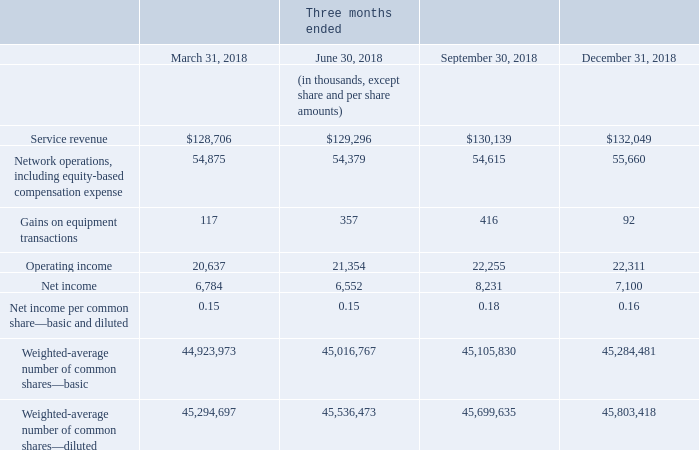11. Quarterly financial information (unaudited): (Continued)
(1) Included in net income for the three months ended September 30, 2019 and December 31, 2019 are an unrealized gain and (loss) on foreign exchange on the Company’s 2024 Notes of $6.1 million and ($4.0) million, respectively.
What are the respective service revenue at March 31 and June 30, 2018?
Answer scale should be: thousand. $128,706, $129,296. What are the respective service revenue at June 30 and September 30, 2018?
Answer scale should be: thousand. $129,296, $130,139. What are the respective service revenue at September 30 and December 31, 2018?
Answer scale should be: thousand. $130,139, $132,049. What is the total service revenue at March 31 and June 30, 2018?
Answer scale should be: thousand. ($128,706 + $129,296) 
Answer: 258002. What is the average service revenue at June 30 and September 30, 2018?
Answer scale should be: thousand. ($129,296 + $130,139)/2 
Answer: 129717.5. What is the percentage change in the service revenue between September 30 and December 31, 2018?
Answer scale should be: percent. ($132,049 - $130,139)/$130,139 
Answer: 1.47. 